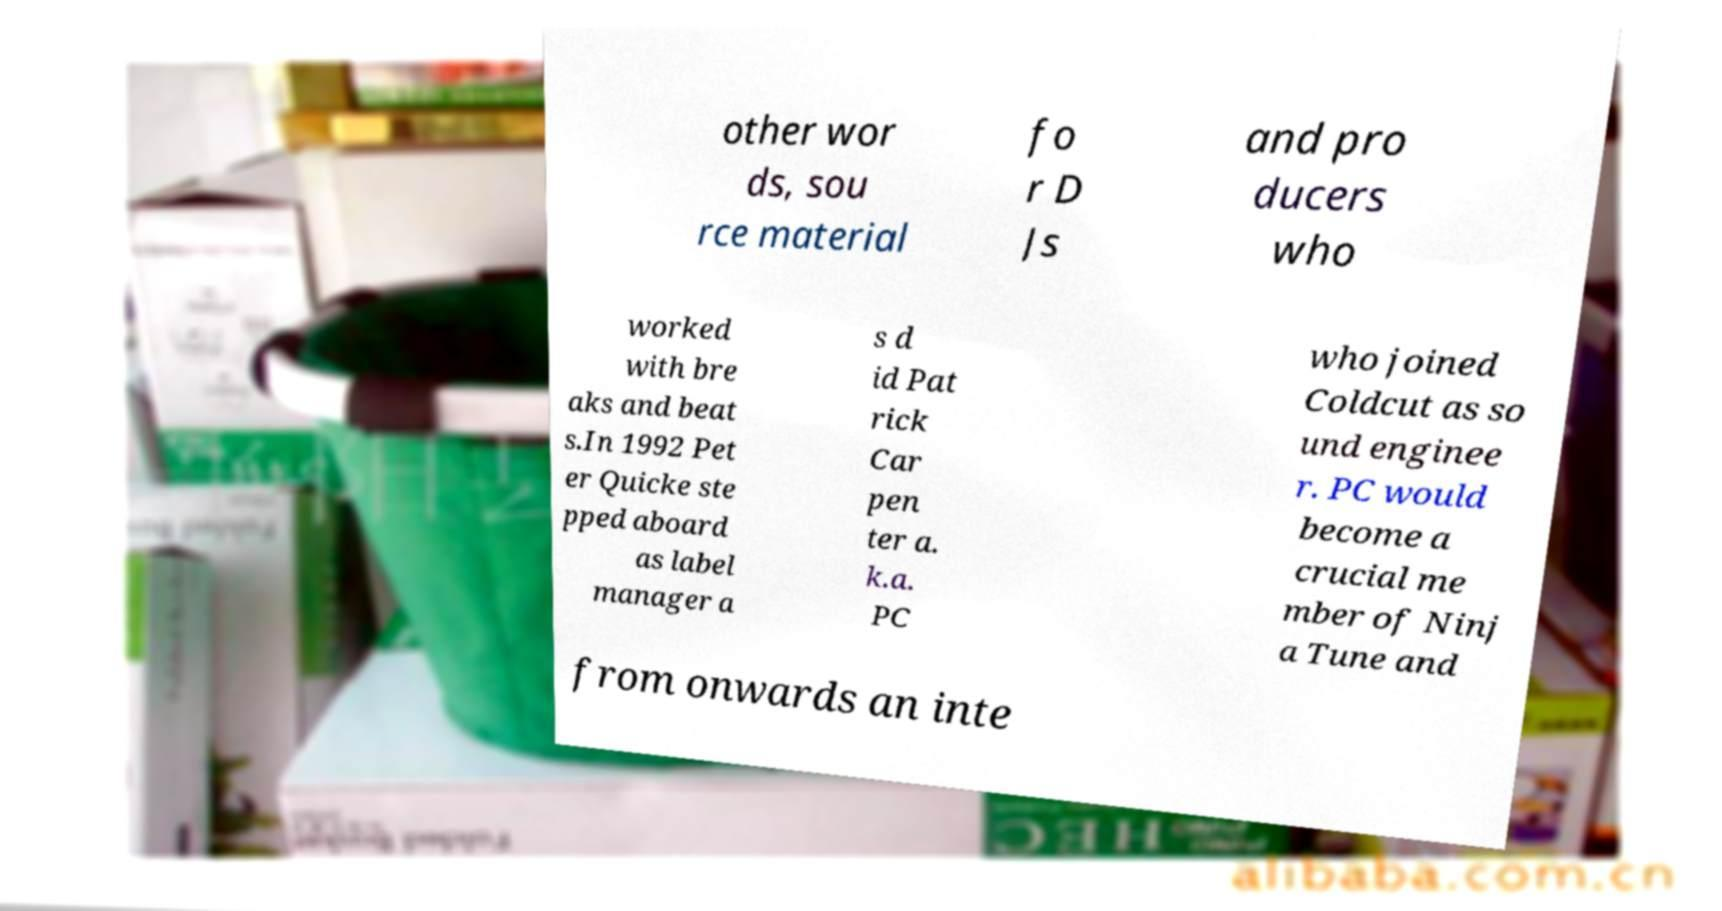There's text embedded in this image that I need extracted. Can you transcribe it verbatim? other wor ds, sou rce material fo r D Js and pro ducers who worked with bre aks and beat s.In 1992 Pet er Quicke ste pped aboard as label manager a s d id Pat rick Car pen ter a. k.a. PC who joined Coldcut as so und enginee r. PC would become a crucial me mber of Ninj a Tune and from onwards an inte 